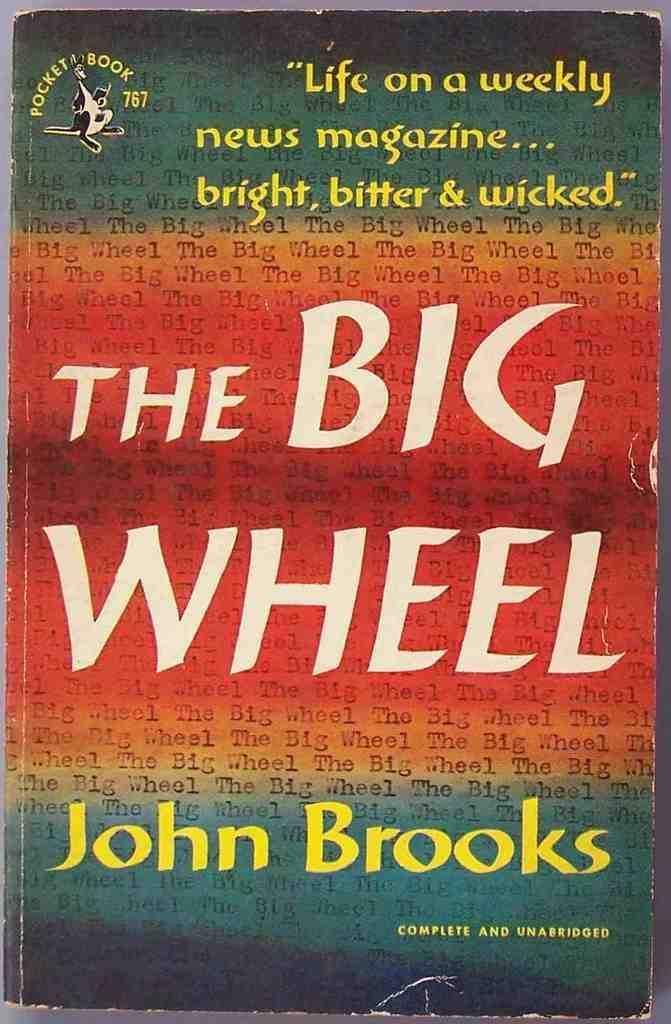Who is the author of this book?
Provide a succinct answer. John brooks. 